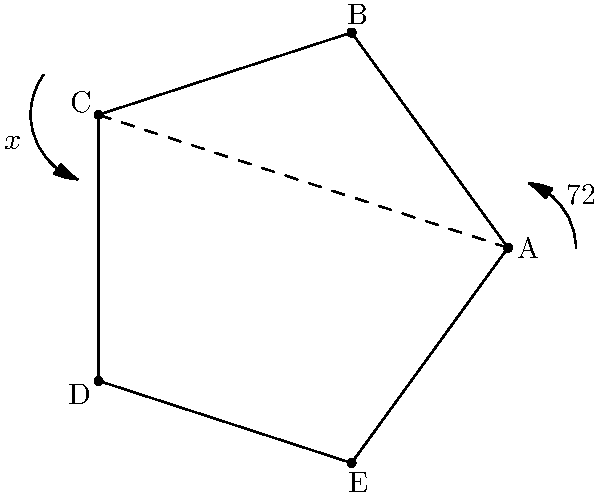In the regular pentagon ABCDE shown above, what is the measure of the exterior angle $x$ in degrees? To find the measure of the exterior angle in a regular pentagon, we can follow these steps:

1) First, recall that the sum of interior angles of any pentagon is $(5-2) \times 180° = 540°$.

2) In a regular pentagon, all interior angles are equal. So, each interior angle measures:
   $$\frac{540°}{5} = 108°$$

3) The exterior angle and the interior angle at any vertex of a polygon are supplementary, meaning they add up to 180°. So we can write:
   $$x + 108° = 180°$$

4) Solving for $x$:
   $$x = 180° - 108° = 72°$$

5) We can verify this result by noting that in any regular polygon, the measure of an exterior angle is:
   $$\frac{360°}{n}$$
   where $n$ is the number of sides. For a pentagon, this gives:
   $$\frac{360°}{5} = 72°$$

Therefore, the measure of the exterior angle $x$ is 72°.
Answer: 72° 